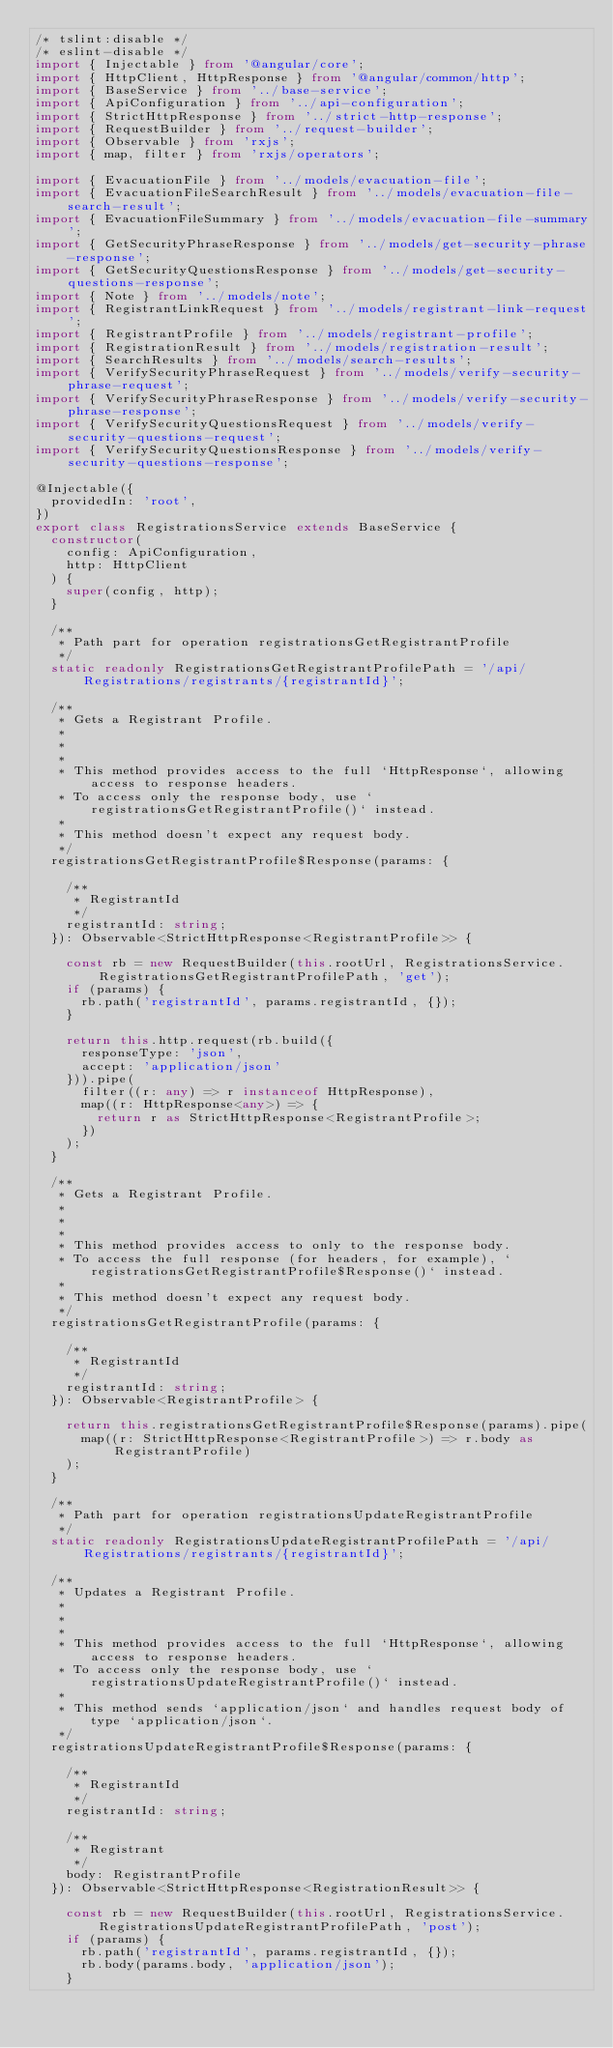<code> <loc_0><loc_0><loc_500><loc_500><_TypeScript_>/* tslint:disable */
/* eslint-disable */
import { Injectable } from '@angular/core';
import { HttpClient, HttpResponse } from '@angular/common/http';
import { BaseService } from '../base-service';
import { ApiConfiguration } from '../api-configuration';
import { StrictHttpResponse } from '../strict-http-response';
import { RequestBuilder } from '../request-builder';
import { Observable } from 'rxjs';
import { map, filter } from 'rxjs/operators';

import { EvacuationFile } from '../models/evacuation-file';
import { EvacuationFileSearchResult } from '../models/evacuation-file-search-result';
import { EvacuationFileSummary } from '../models/evacuation-file-summary';
import { GetSecurityPhraseResponse } from '../models/get-security-phrase-response';
import { GetSecurityQuestionsResponse } from '../models/get-security-questions-response';
import { Note } from '../models/note';
import { RegistrantLinkRequest } from '../models/registrant-link-request';
import { RegistrantProfile } from '../models/registrant-profile';
import { RegistrationResult } from '../models/registration-result';
import { SearchResults } from '../models/search-results';
import { VerifySecurityPhraseRequest } from '../models/verify-security-phrase-request';
import { VerifySecurityPhraseResponse } from '../models/verify-security-phrase-response';
import { VerifySecurityQuestionsRequest } from '../models/verify-security-questions-request';
import { VerifySecurityQuestionsResponse } from '../models/verify-security-questions-response';

@Injectable({
  providedIn: 'root',
})
export class RegistrationsService extends BaseService {
  constructor(
    config: ApiConfiguration,
    http: HttpClient
  ) {
    super(config, http);
  }

  /**
   * Path part for operation registrationsGetRegistrantProfile
   */
  static readonly RegistrationsGetRegistrantProfilePath = '/api/Registrations/registrants/{registrantId}';

  /**
   * Gets a Registrant Profile.
   *
   *
   *
   * This method provides access to the full `HttpResponse`, allowing access to response headers.
   * To access only the response body, use `registrationsGetRegistrantProfile()` instead.
   *
   * This method doesn't expect any request body.
   */
  registrationsGetRegistrantProfile$Response(params: {

    /**
     * RegistrantId
     */
    registrantId: string;
  }): Observable<StrictHttpResponse<RegistrantProfile>> {

    const rb = new RequestBuilder(this.rootUrl, RegistrationsService.RegistrationsGetRegistrantProfilePath, 'get');
    if (params) {
      rb.path('registrantId', params.registrantId, {});
    }

    return this.http.request(rb.build({
      responseType: 'json',
      accept: 'application/json'
    })).pipe(
      filter((r: any) => r instanceof HttpResponse),
      map((r: HttpResponse<any>) => {
        return r as StrictHttpResponse<RegistrantProfile>;
      })
    );
  }

  /**
   * Gets a Registrant Profile.
   *
   *
   *
   * This method provides access to only to the response body.
   * To access the full response (for headers, for example), `registrationsGetRegistrantProfile$Response()` instead.
   *
   * This method doesn't expect any request body.
   */
  registrationsGetRegistrantProfile(params: {

    /**
     * RegistrantId
     */
    registrantId: string;
  }): Observable<RegistrantProfile> {

    return this.registrationsGetRegistrantProfile$Response(params).pipe(
      map((r: StrictHttpResponse<RegistrantProfile>) => r.body as RegistrantProfile)
    );
  }

  /**
   * Path part for operation registrationsUpdateRegistrantProfile
   */
  static readonly RegistrationsUpdateRegistrantProfilePath = '/api/Registrations/registrants/{registrantId}';

  /**
   * Updates a Registrant Profile.
   *
   *
   *
   * This method provides access to the full `HttpResponse`, allowing access to response headers.
   * To access only the response body, use `registrationsUpdateRegistrantProfile()` instead.
   *
   * This method sends `application/json` and handles request body of type `application/json`.
   */
  registrationsUpdateRegistrantProfile$Response(params: {

    /**
     * RegistrantId
     */
    registrantId: string;

    /**
     * Registrant
     */
    body: RegistrantProfile
  }): Observable<StrictHttpResponse<RegistrationResult>> {

    const rb = new RequestBuilder(this.rootUrl, RegistrationsService.RegistrationsUpdateRegistrantProfilePath, 'post');
    if (params) {
      rb.path('registrantId', params.registrantId, {});
      rb.body(params.body, 'application/json');
    }
</code> 